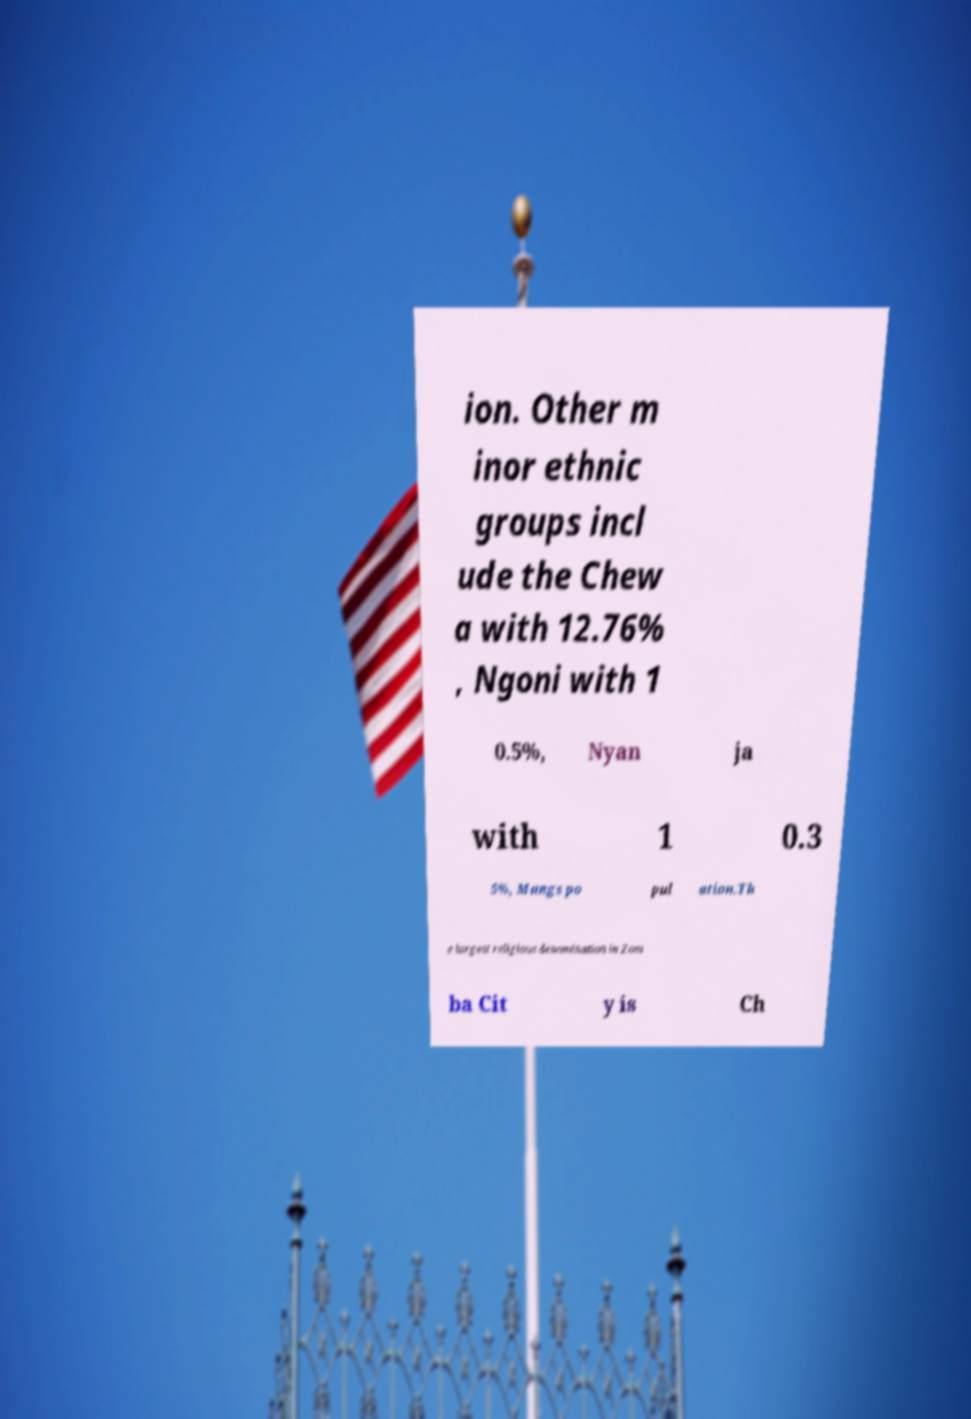Please identify and transcribe the text found in this image. ion. Other m inor ethnic groups incl ude the Chew a with 12.76% , Ngoni with 1 0.5%, Nyan ja with 1 0.3 5%, Mangs po pul ation.Th e largest religious denomination in Zom ba Cit y is Ch 